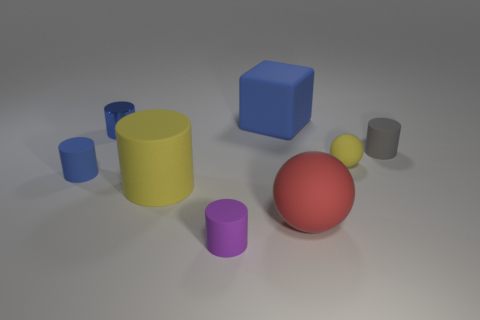Subtract all cyan balls. How many blue cylinders are left? 2 Subtract 1 cylinders. How many cylinders are left? 4 Subtract all purple cylinders. How many cylinders are left? 4 Subtract all blue rubber cylinders. How many cylinders are left? 4 Subtract all red cylinders. Subtract all blue blocks. How many cylinders are left? 5 Add 2 large yellow cylinders. How many objects exist? 10 Subtract all spheres. How many objects are left? 6 Add 6 small cylinders. How many small cylinders are left? 10 Add 7 metallic things. How many metallic things exist? 8 Subtract 0 cyan cylinders. How many objects are left? 8 